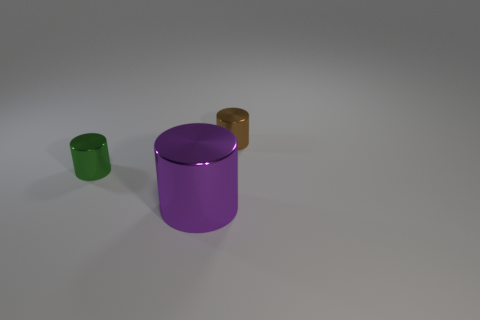There is a thing in front of the small metal cylinder left of the tiny brown thing; what number of tiny green cylinders are to the right of it?
Offer a very short reply. 0. Are there any other things that are the same shape as the green thing?
Offer a terse response. Yes. How many objects are either purple objects or green cylinders?
Your answer should be compact. 2. There is a large shiny object; is its shape the same as the small metallic object behind the green object?
Your answer should be very brief. Yes. There is a small thing that is behind the tiny green metallic cylinder; what is its shape?
Your answer should be compact. Cylinder. Does the brown metallic object have the same shape as the big metal thing?
Offer a terse response. Yes. There is a green shiny thing that is the same shape as the big purple object; what is its size?
Your answer should be compact. Small. Do the metal object to the right of the purple object and the green metal cylinder have the same size?
Give a very brief answer. Yes. There is a shiny object that is both right of the small green shiny thing and left of the tiny brown cylinder; how big is it?
Offer a very short reply. Large. What number of tiny objects are the same color as the big cylinder?
Provide a succinct answer. 0. 